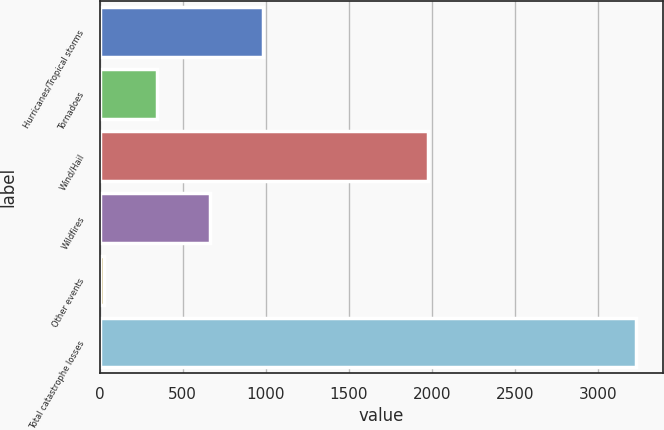Convert chart to OTSL. <chart><loc_0><loc_0><loc_500><loc_500><bar_chart><fcel>Hurricanes/Tropical storms<fcel>Tornadoes<fcel>Wind/Hail<fcel>Wildfires<fcel>Other events<fcel>Total catastrophe losses<nl><fcel>985.2<fcel>344.4<fcel>1973<fcel>664.8<fcel>24<fcel>3228<nl></chart> 